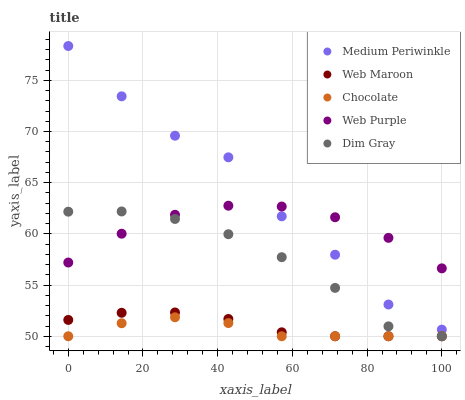Does Chocolate have the minimum area under the curve?
Answer yes or no. Yes. Does Medium Periwinkle have the maximum area under the curve?
Answer yes or no. Yes. Does Web Purple have the minimum area under the curve?
Answer yes or no. No. Does Web Purple have the maximum area under the curve?
Answer yes or no. No. Is Web Maroon the smoothest?
Answer yes or no. Yes. Is Medium Periwinkle the roughest?
Answer yes or no. Yes. Is Web Purple the smoothest?
Answer yes or no. No. Is Web Purple the roughest?
Answer yes or no. No. Does Web Maroon have the lowest value?
Answer yes or no. Yes. Does Web Purple have the lowest value?
Answer yes or no. No. Does Medium Periwinkle have the highest value?
Answer yes or no. Yes. Does Web Purple have the highest value?
Answer yes or no. No. Is Chocolate less than Medium Periwinkle?
Answer yes or no. Yes. Is Web Purple greater than Web Maroon?
Answer yes or no. Yes. Does Dim Gray intersect Chocolate?
Answer yes or no. Yes. Is Dim Gray less than Chocolate?
Answer yes or no. No. Is Dim Gray greater than Chocolate?
Answer yes or no. No. Does Chocolate intersect Medium Periwinkle?
Answer yes or no. No. 